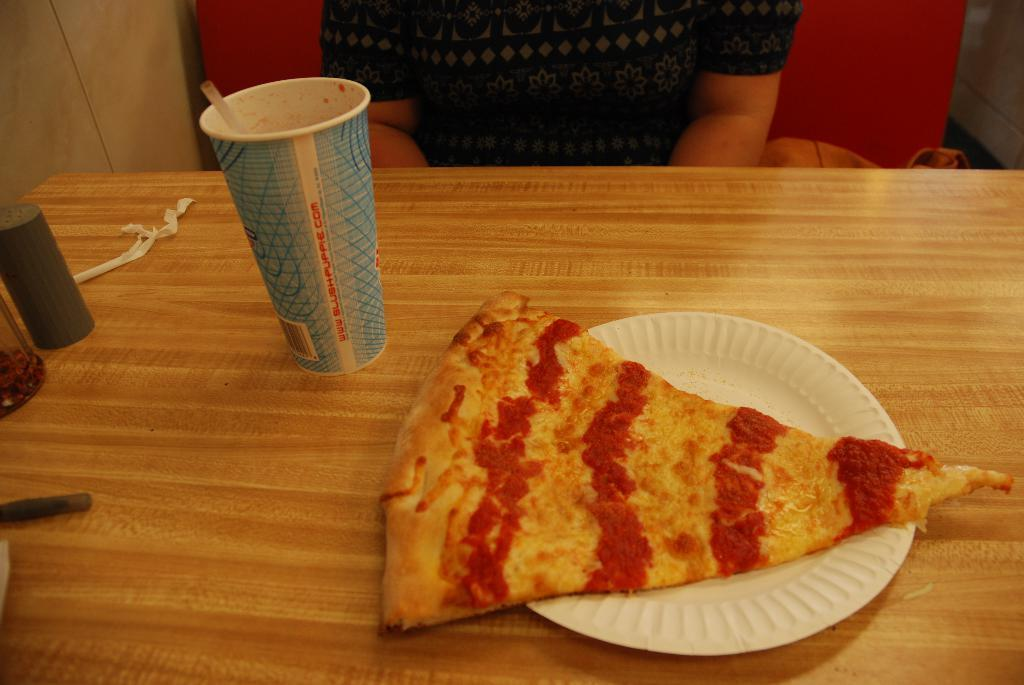What piece of furniture is present in the image? There is a table in the image. What is placed on the table? There is a plate, a glass, a bottle, and a pizza on the table. Can you describe the person in the background? There is a person sitting in the background. What can be seen behind the person? There is a wall in the background. What type of scent is emanating from the cast in the image? There is no cast present in the image, and therefore no scent can be attributed to it. 